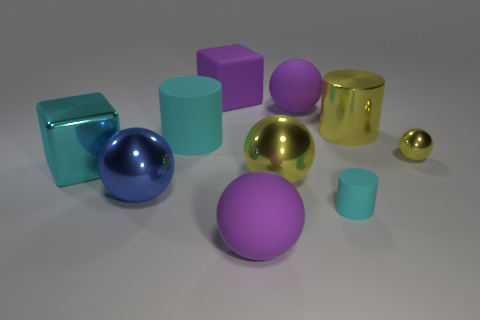Subtract 2 spheres. How many spheres are left? 3 Subtract all blue spheres. How many spheres are left? 4 Subtract all big cylinders. How many cylinders are left? 1 Subtract all green balls. Subtract all green cylinders. How many balls are left? 5 Subtract all cylinders. How many objects are left? 7 Add 5 blue metal balls. How many blue metal balls exist? 6 Subtract 0 blue cylinders. How many objects are left? 10 Subtract all blue shiny objects. Subtract all matte cylinders. How many objects are left? 7 Add 2 tiny metallic balls. How many tiny metallic balls are left? 3 